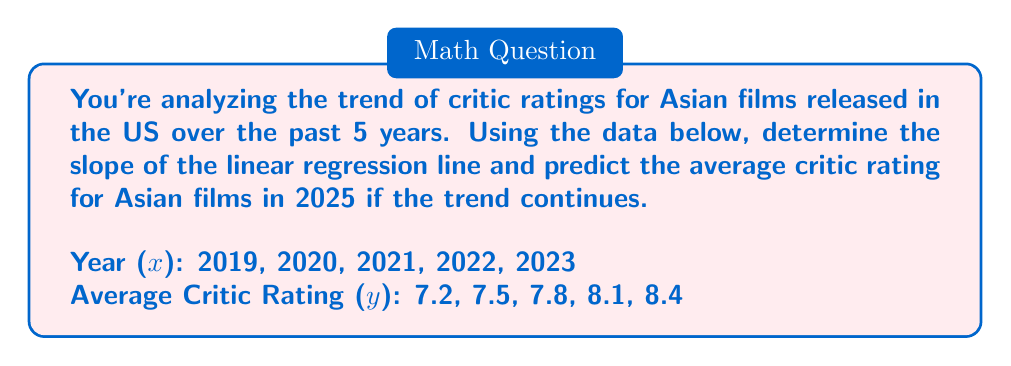Solve this math problem. To solve this problem, we'll use the linear regression formula:

1. Calculate the slope (m) using:

   $$ m = \frac{n\sum xy - \sum x \sum y}{n\sum x^2 - (\sum x)^2} $$

   Where n = 5 (number of data points)

2. Calculate necessary sums:
   $\sum x = 2019 + 2020 + 2021 + 2022 + 2023 = 10105$
   $\sum y = 7.2 + 7.5 + 7.8 + 8.1 + 8.4 = 39$
   $\sum xy = (2019 * 7.2) + (2020 * 7.5) + (2021 * 7.8) + (2022 * 8.1) + (2023 * 8.4) = 78409.5$
   $\sum x^2 = 2019^2 + 2020^2 + 2021^2 + 2022^2 + 2023^2 = 20420555$

3. Plug into the slope formula:
   $$ m = \frac{5(78409.5) - (10105)(39)}{5(20420555) - (10105)^2} = 0.3 $$

4. To predict the rating for 2025, use the point-slope form:
   $y - y_1 = m(x - x_1)$
   
   Using (2023, 8.4) as $(x_1, y_1)$:
   $y - 8.4 = 0.3(2025 - 2023)$
   $y - 8.4 = 0.3(2) = 0.6$
   $y = 8.4 + 0.6 = 9$
Answer: Slope: 0.3; Predicted 2025 rating: 9 